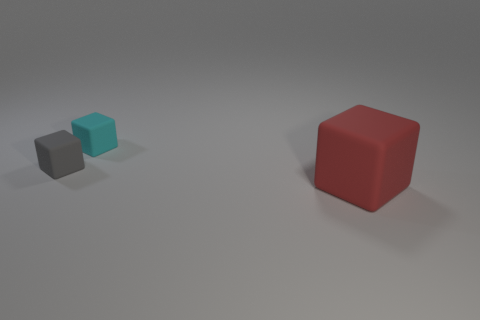Add 1 cyan matte blocks. How many objects exist? 4 Subtract all gray blocks. How many blocks are left? 2 Subtract 1 blocks. How many blocks are left? 2 Subtract all red cubes. Subtract all gray cylinders. How many cubes are left? 2 Subtract all red balls. How many red blocks are left? 1 Subtract all large green blocks. Subtract all large matte objects. How many objects are left? 2 Add 2 tiny rubber blocks. How many tiny rubber blocks are left? 4 Add 1 small matte objects. How many small matte objects exist? 3 Subtract all gray cubes. How many cubes are left? 2 Subtract 0 brown cylinders. How many objects are left? 3 